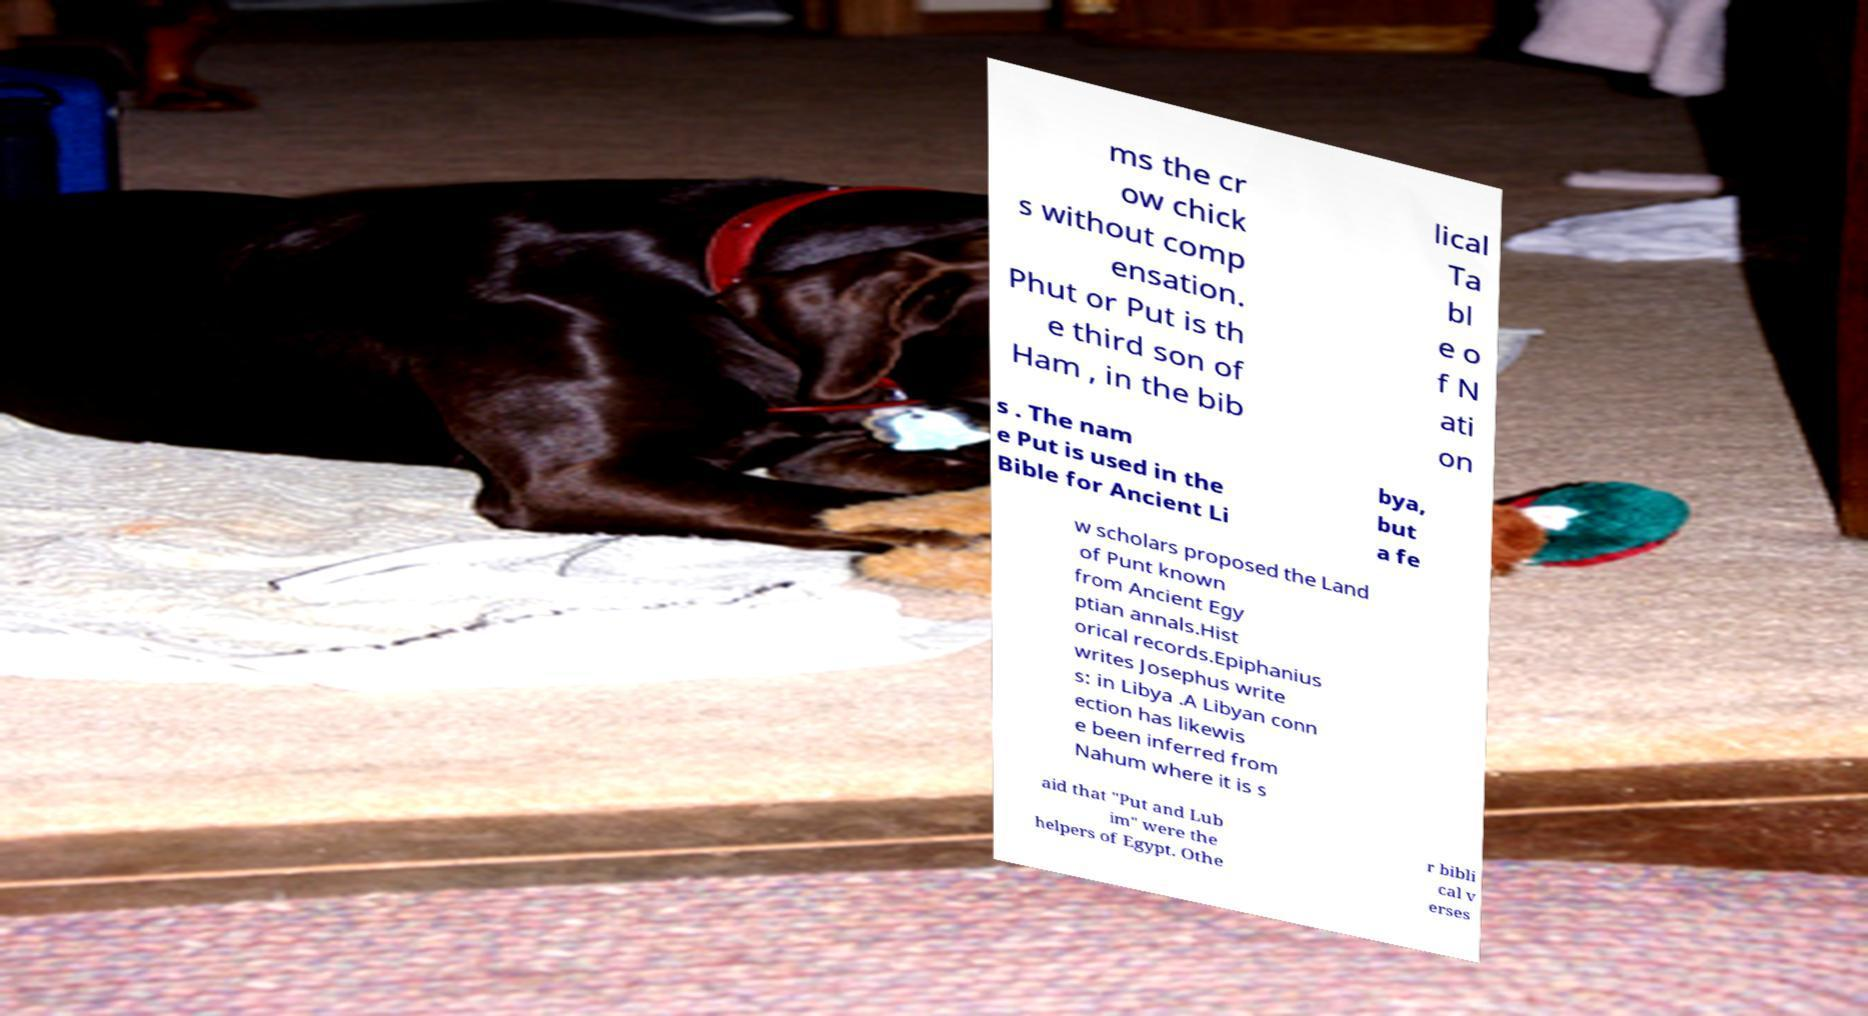Could you assist in decoding the text presented in this image and type it out clearly? ms the cr ow chick s without comp ensation. Phut or Put is th e third son of Ham , in the bib lical Ta bl e o f N ati on s . The nam e Put is used in the Bible for Ancient Li bya, but a fe w scholars proposed the Land of Punt known from Ancient Egy ptian annals.Hist orical records.Epiphanius writes Josephus write s: in Libya .A Libyan conn ection has likewis e been inferred from Nahum where it is s aid that "Put and Lub im" were the helpers of Egypt. Othe r bibli cal v erses 